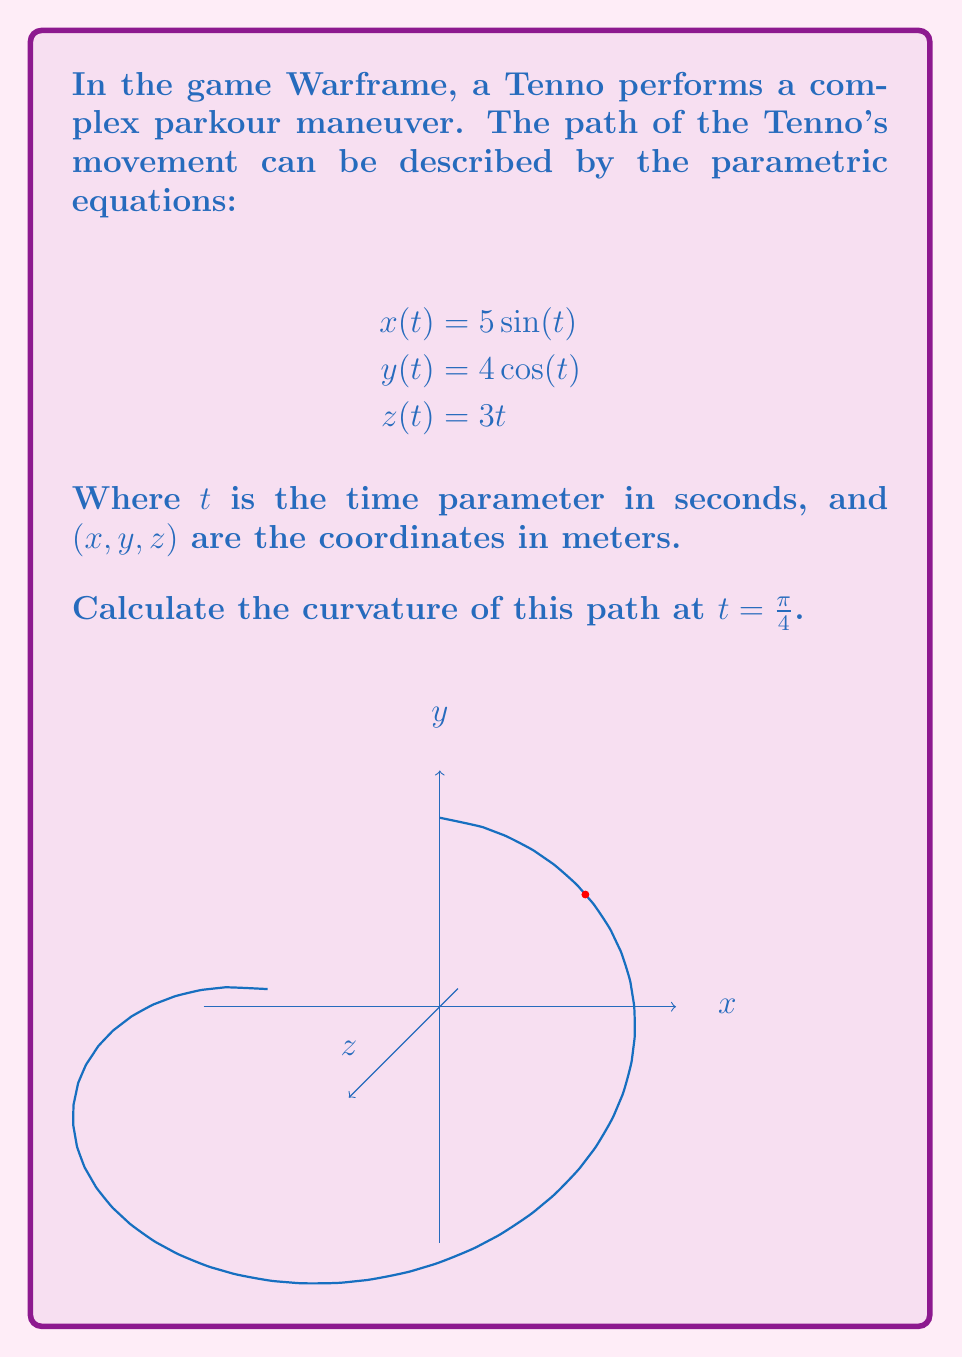Show me your answer to this math problem. To find the curvature, we'll use the formula for parametric curves in 3D space:

$$\kappa = \frac{\sqrt{|\mathbf{r}'(t) \times \mathbf{r}''(t)|^2}}{|\mathbf{r}'(t)|^3}$$

Where $\mathbf{r}(t) = (x(t), y(t), z(t))$ is the position vector.

Step 1: Calculate $\mathbf{r}'(t)$
$$\mathbf{r}'(t) = (5\cos(t), -4\sin(t), 3)$$

Step 2: Calculate $\mathbf{r}''(t)$
$$\mathbf{r}''(t) = (-5\sin(t), -4\cos(t), 0)$$

Step 3: Calculate $\mathbf{r}'(t) \times \mathbf{r}''(t)$
$$\mathbf{r}'(t) \times \mathbf{r}''(t) = (12\cos(t), 15\sin(t), 20\sin^2(t) + 16\cos^2(t))$$

Step 4: Calculate $|\mathbf{r}'(t) \times \mathbf{r}''(t)|^2$ at $t = \frac{\pi}{4}$
$$|\mathbf{r}'(\frac{\pi}{4}) \times \mathbf{r}''(\frac{\pi}{4})|^2 = (12\frac{\sqrt{2}}{2})^2 + (15\frac{\sqrt{2}}{2})^2 + (20\frac{1}{2} + 16\frac{1}{2})^2 = 360.5$$

Step 5: Calculate $|\mathbf{r}'(t)|^3$ at $t = \frac{\pi}{4}$
$$|\mathbf{r}'(\frac{\pi}{4})|^3 = (25\frac{1}{2} + 16\frac{1}{2} + 9)^3 = 50^3 = 125000$$

Step 6: Apply the curvature formula
$$\kappa = \frac{\sqrt{360.5}}{125000} \approx 0.00152$$
Answer: $\kappa \approx 0.00152 \text{ m}^{-1}$ 